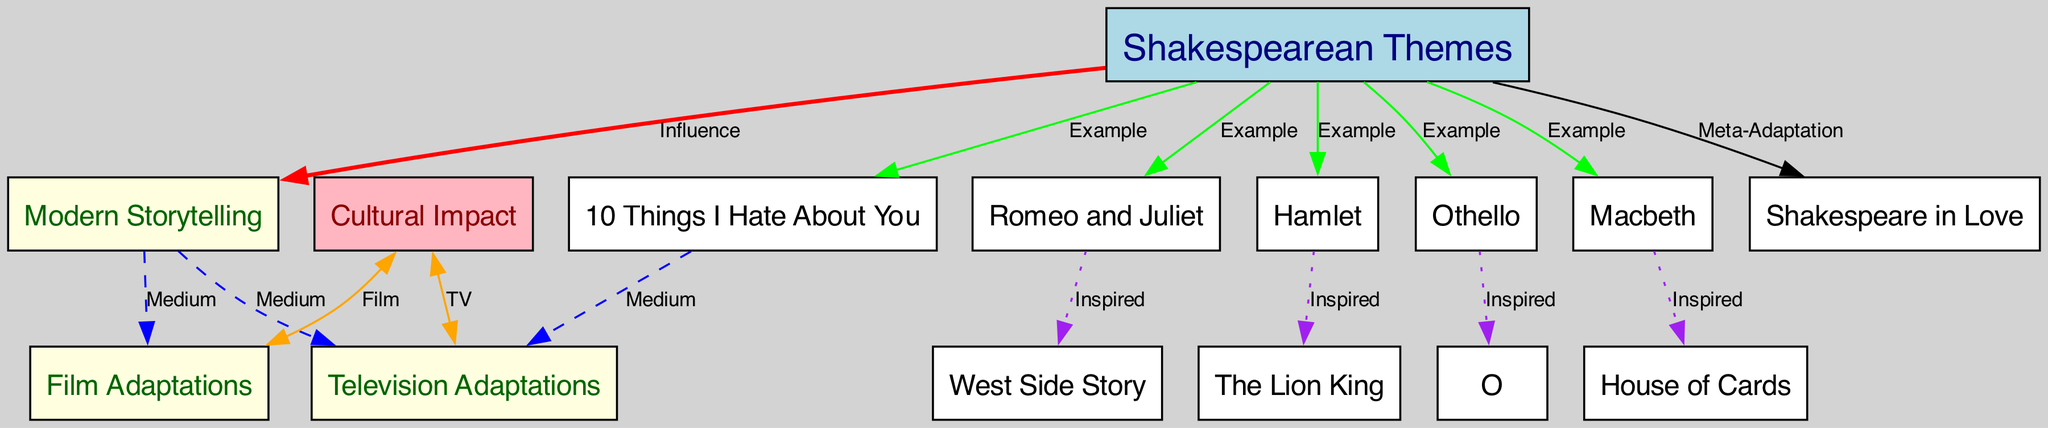What is the main influence depicted in the diagram? The diagram shows that Shakespearean Themes influence Modern Storytelling, which is represented by the direct edge labeled 'Influence' connecting the two nodes.
Answer: Influence How many examples of Shakespearean themes are listed in the diagram? There are five examples of Shakespearean themes identified, including Romeo and Juliet, Hamlet, Othello, Macbeth, and 10 Things I Hate About You.
Answer: Five Which film adaptation is inspired by Othello? The adaptation inspired by Othello is named "O," which is represented in the diagram as a direct connection from Othello to O, labeled 'Inspired.'
Answer: O Which medium is represented connecting Modern Storytelling to Film Adaptations? The connection between Modern Storytelling and Film Adaptations is shown by the edge labeled 'Medium,' which is dashed to illustrate that it is a method of storytelling.
Answer: Medium Which themes inspired the television series "House of Cards"? The series "House of Cards" is inspired by the theme of Macbeth, as indicated by the direct link from Macbeth to House of Cards in the diagram labeled 'Inspired.'
Answer: Macbeth How many nodes are there representing modern storytelling mediums? There are two nodes that represent modern storytelling mediums: Film Adaptations and Television Adaptations.
Answer: Two What does the edge labeled 'Meta-Adaptation' connect? The edge labeled 'Meta-Adaptation' connects the node for Shakespearean Themes to the node for Shakespeare in Love, indicating a specific example of an adaptation that references Shakespearean works.
Answer: Shakespeare in Love How do modern adaptations impact film and television? The Cultural Impact node connects to both Film Adaptations and Television Adaptations, indicating that both mediums are influenced by the cultural relevance of Shakespearean themes.
Answer: Cultural Impact What type of relationship is represented by the connection between "Romeo and Juliet" and "West Side Story"? The relationship between "Romeo and Juliet" and "West Side Story" is marked as 'Inspired,' indicating that West Side Story is a modern adaptation influenced by the themes of Romeo and Juliet.
Answer: Inspired 